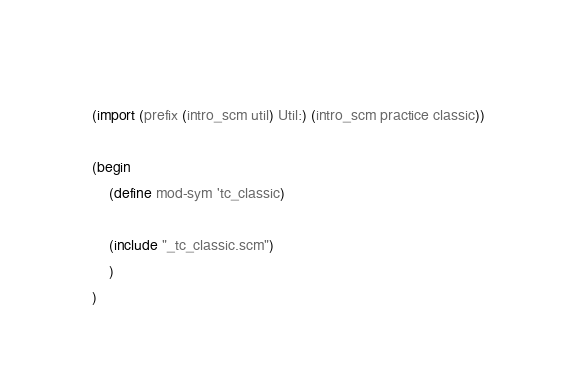Convert code to text. <code><loc_0><loc_0><loc_500><loc_500><_Scheme_>    
    (import (prefix (intro_scm util) Util:) (intro_scm practice classic))
    
    (begin
		(define mod-sym 'tc_classic)
        
        (include "_tc_classic.scm")
        )
	)
</code> 